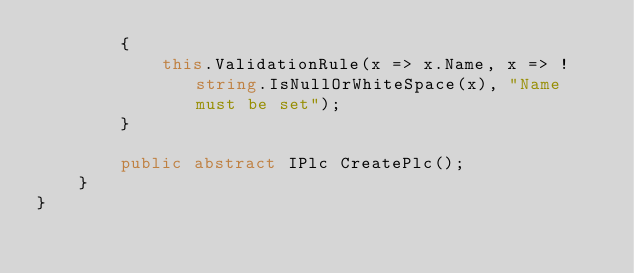Convert code to text. <code><loc_0><loc_0><loc_500><loc_500><_C#_>        {
            this.ValidationRule(x => x.Name, x => !string.IsNullOrWhiteSpace(x), "Name must be set");
        }

        public abstract IPlc CreatePlc();
    }
}</code> 